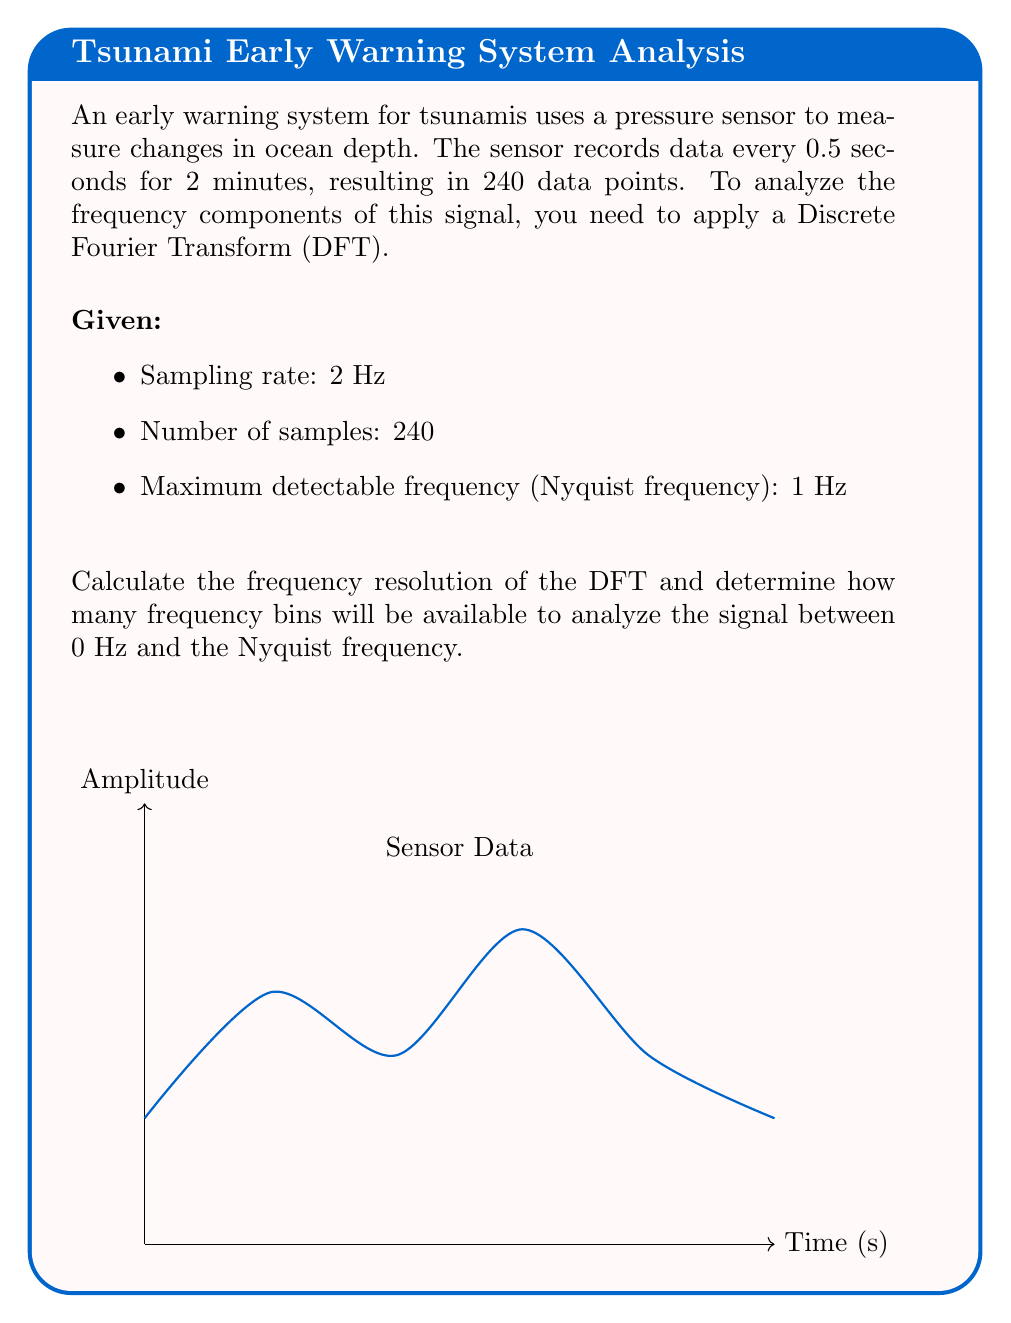Solve this math problem. To solve this problem, we'll follow these steps:

1) Calculate the frequency resolution:
   The frequency resolution (Δf) is given by the formula:
   $$\Delta f = \frac{f_s}{N}$$
   Where $f_s$ is the sampling frequency and $N$ is the number of samples.

   $f_s = 2$ Hz (given)
   $N = 240$ (given)

   $$\Delta f = \frac{2}{240} = \frac{1}{120} \approx 0.00833 \text{ Hz}$$

2) Calculate the number of frequency bins:
   The number of frequency bins from 0 Hz to the Nyquist frequency is:
   $$\text{Number of bins} = \frac{f_{Nyquist}}{\Delta f} + 1$$

   $f_{Nyquist} = 1$ Hz (given)
   $\Delta f = \frac{1}{120}$ Hz (calculated in step 1)

   $$\text{Number of bins} = \frac{1}{\frac{1}{120}} + 1 = 120 + 1 = 121$$

The '+1' is included because we count both the 0 Hz bin and the Nyquist frequency bin.
Answer: Frequency resolution: $\frac{1}{120}$ Hz; Number of frequency bins: 121 